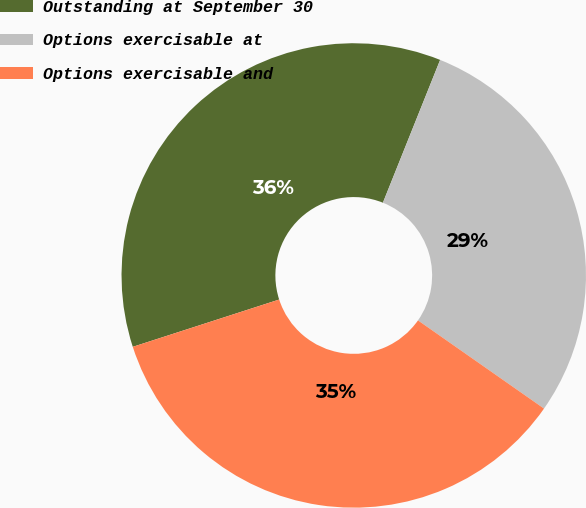<chart> <loc_0><loc_0><loc_500><loc_500><pie_chart><fcel>Outstanding at September 30<fcel>Options exercisable at<fcel>Options exercisable and<nl><fcel>36.04%<fcel>28.65%<fcel>35.31%<nl></chart> 